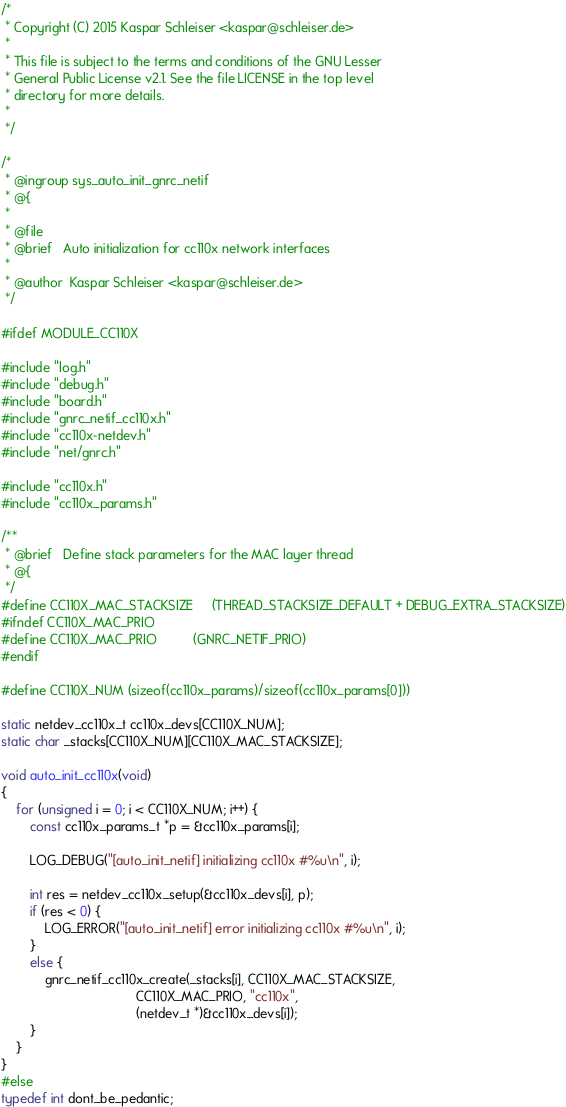Convert code to text. <code><loc_0><loc_0><loc_500><loc_500><_C_>/*
 * Copyright (C) 2015 Kaspar Schleiser <kaspar@schleiser.de>
 *
 * This file is subject to the terms and conditions of the GNU Lesser
 * General Public License v2.1. See the file LICENSE in the top level
 * directory for more details.
 *
 */

/*
 * @ingroup sys_auto_init_gnrc_netif
 * @{
 *
 * @file
 * @brief   Auto initialization for cc110x network interfaces
 *
 * @author  Kaspar Schleiser <kaspar@schleiser.de>
 */

#ifdef MODULE_CC110X

#include "log.h"
#include "debug.h"
#include "board.h"
#include "gnrc_netif_cc110x.h"
#include "cc110x-netdev.h"
#include "net/gnrc.h"

#include "cc110x.h"
#include "cc110x_params.h"

/**
 * @brief   Define stack parameters for the MAC layer thread
 * @{
 */
#define CC110X_MAC_STACKSIZE     (THREAD_STACKSIZE_DEFAULT + DEBUG_EXTRA_STACKSIZE)
#ifndef CC110X_MAC_PRIO
#define CC110X_MAC_PRIO          (GNRC_NETIF_PRIO)
#endif

#define CC110X_NUM (sizeof(cc110x_params)/sizeof(cc110x_params[0]))

static netdev_cc110x_t cc110x_devs[CC110X_NUM];
static char _stacks[CC110X_NUM][CC110X_MAC_STACKSIZE];

void auto_init_cc110x(void)
{
    for (unsigned i = 0; i < CC110X_NUM; i++) {
        const cc110x_params_t *p = &cc110x_params[i];

        LOG_DEBUG("[auto_init_netif] initializing cc110x #%u\n", i);

        int res = netdev_cc110x_setup(&cc110x_devs[i], p);
        if (res < 0) {
            LOG_ERROR("[auto_init_netif] error initializing cc110x #%u\n", i);
        }
        else {
            gnrc_netif_cc110x_create(_stacks[i], CC110X_MAC_STACKSIZE,
                                     CC110X_MAC_PRIO, "cc110x",
                                     (netdev_t *)&cc110x_devs[i]);
        }
    }
}
#else
typedef int dont_be_pedantic;</code> 